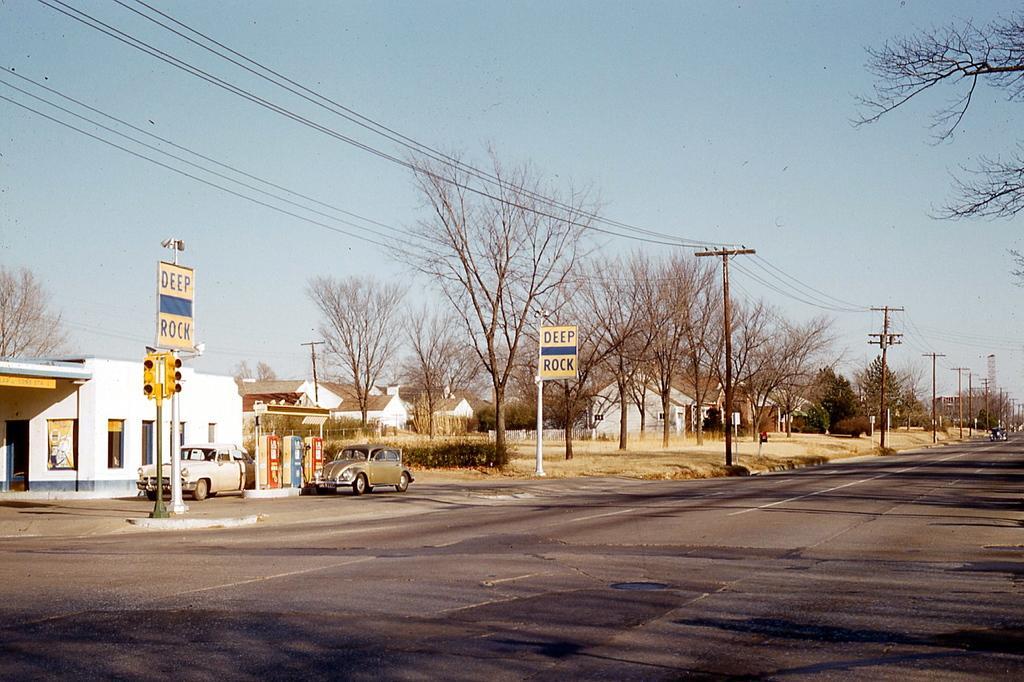Please provide a concise description of this image. These are the buildings with the windows. This looks like a filling station. I can see two cars. This looks like a traffic signal, which is attached to a pole. These are the current poles with the current wires. I can see the trees with branches. I think these are the bushes. I can see the name boards, which are attached to the poles. This is the sky. 